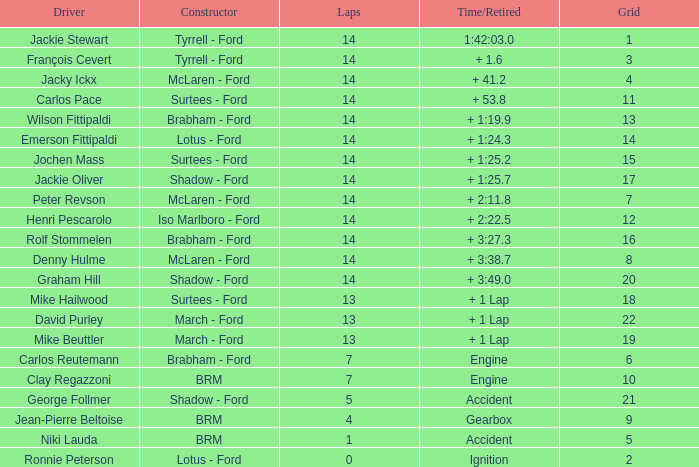What grad has a Time/Retired of + 1:24.3? 14.0. 